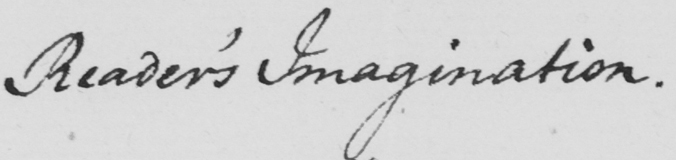Transcribe the text shown in this historical manuscript line. Reader ' s Imagination . 